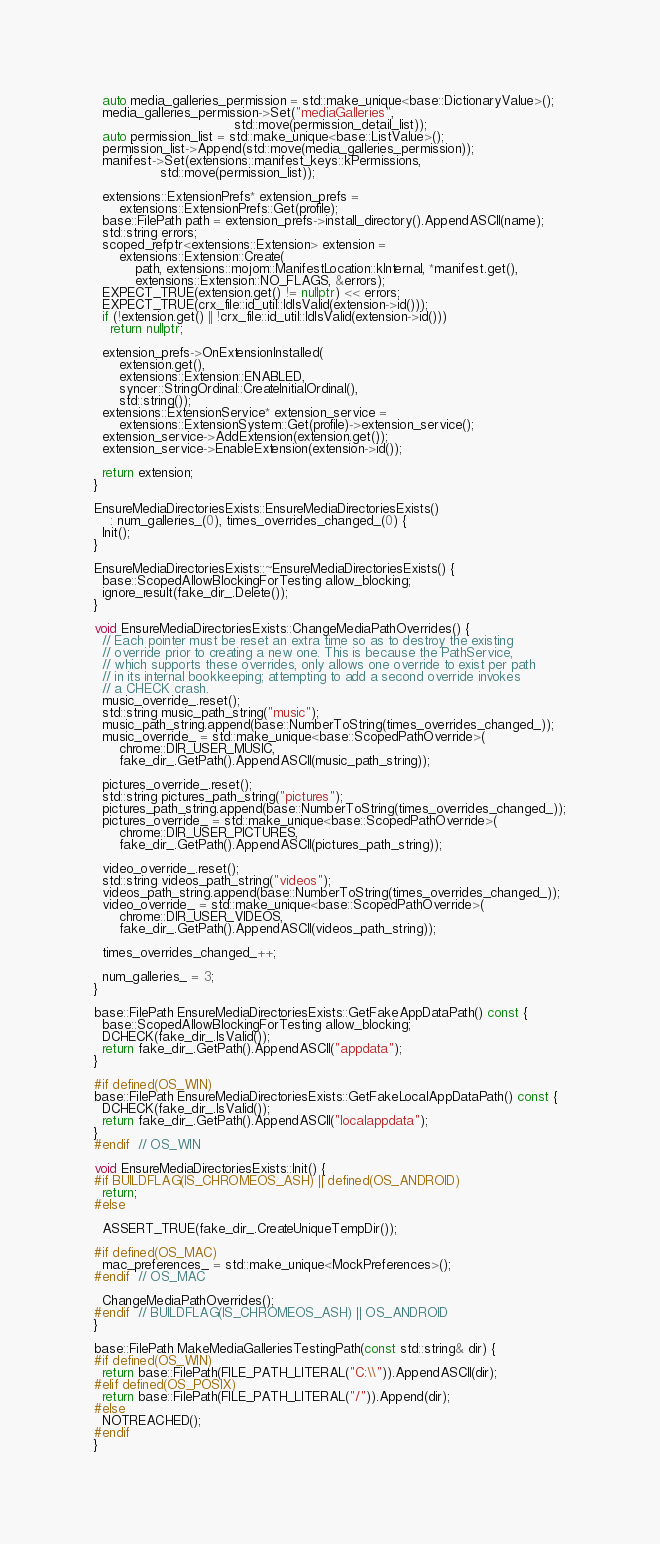Convert code to text. <code><loc_0><loc_0><loc_500><loc_500><_C++_>  auto media_galleries_permission = std::make_unique<base::DictionaryValue>();
  media_galleries_permission->Set("mediaGalleries",
                                  std::move(permission_detail_list));
  auto permission_list = std::make_unique<base::ListValue>();
  permission_list->Append(std::move(media_galleries_permission));
  manifest->Set(extensions::manifest_keys::kPermissions,
                std::move(permission_list));

  extensions::ExtensionPrefs* extension_prefs =
      extensions::ExtensionPrefs::Get(profile);
  base::FilePath path = extension_prefs->install_directory().AppendASCII(name);
  std::string errors;
  scoped_refptr<extensions::Extension> extension =
      extensions::Extension::Create(
          path, extensions::mojom::ManifestLocation::kInternal, *manifest.get(),
          extensions::Extension::NO_FLAGS, &errors);
  EXPECT_TRUE(extension.get() != nullptr) << errors;
  EXPECT_TRUE(crx_file::id_util::IdIsValid(extension->id()));
  if (!extension.get() || !crx_file::id_util::IdIsValid(extension->id()))
    return nullptr;

  extension_prefs->OnExtensionInstalled(
      extension.get(),
      extensions::Extension::ENABLED,
      syncer::StringOrdinal::CreateInitialOrdinal(),
      std::string());
  extensions::ExtensionService* extension_service =
      extensions::ExtensionSystem::Get(profile)->extension_service();
  extension_service->AddExtension(extension.get());
  extension_service->EnableExtension(extension->id());

  return extension;
}

EnsureMediaDirectoriesExists::EnsureMediaDirectoriesExists()
    : num_galleries_(0), times_overrides_changed_(0) {
  Init();
}

EnsureMediaDirectoriesExists::~EnsureMediaDirectoriesExists() {
  base::ScopedAllowBlockingForTesting allow_blocking;
  ignore_result(fake_dir_.Delete());
}

void EnsureMediaDirectoriesExists::ChangeMediaPathOverrides() {
  // Each pointer must be reset an extra time so as to destroy the existing
  // override prior to creating a new one. This is because the PathService,
  // which supports these overrides, only allows one override to exist per path
  // in its internal bookkeeping; attempting to add a second override invokes
  // a CHECK crash.
  music_override_.reset();
  std::string music_path_string("music");
  music_path_string.append(base::NumberToString(times_overrides_changed_));
  music_override_ = std::make_unique<base::ScopedPathOverride>(
      chrome::DIR_USER_MUSIC,
      fake_dir_.GetPath().AppendASCII(music_path_string));

  pictures_override_.reset();
  std::string pictures_path_string("pictures");
  pictures_path_string.append(base::NumberToString(times_overrides_changed_));
  pictures_override_ = std::make_unique<base::ScopedPathOverride>(
      chrome::DIR_USER_PICTURES,
      fake_dir_.GetPath().AppendASCII(pictures_path_string));

  video_override_.reset();
  std::string videos_path_string("videos");
  videos_path_string.append(base::NumberToString(times_overrides_changed_));
  video_override_ = std::make_unique<base::ScopedPathOverride>(
      chrome::DIR_USER_VIDEOS,
      fake_dir_.GetPath().AppendASCII(videos_path_string));

  times_overrides_changed_++;

  num_galleries_ = 3;
}

base::FilePath EnsureMediaDirectoriesExists::GetFakeAppDataPath() const {
  base::ScopedAllowBlockingForTesting allow_blocking;
  DCHECK(fake_dir_.IsValid());
  return fake_dir_.GetPath().AppendASCII("appdata");
}

#if defined(OS_WIN)
base::FilePath EnsureMediaDirectoriesExists::GetFakeLocalAppDataPath() const {
  DCHECK(fake_dir_.IsValid());
  return fake_dir_.GetPath().AppendASCII("localappdata");
}
#endif  // OS_WIN

void EnsureMediaDirectoriesExists::Init() {
#if BUILDFLAG(IS_CHROMEOS_ASH) || defined(OS_ANDROID)
  return;
#else

  ASSERT_TRUE(fake_dir_.CreateUniqueTempDir());

#if defined(OS_MAC)
  mac_preferences_ = std::make_unique<MockPreferences>();
#endif  // OS_MAC

  ChangeMediaPathOverrides();
#endif  // BUILDFLAG(IS_CHROMEOS_ASH) || OS_ANDROID
}

base::FilePath MakeMediaGalleriesTestingPath(const std::string& dir) {
#if defined(OS_WIN)
  return base::FilePath(FILE_PATH_LITERAL("C:\\")).AppendASCII(dir);
#elif defined(OS_POSIX)
  return base::FilePath(FILE_PATH_LITERAL("/")).Append(dir);
#else
  NOTREACHED();
#endif
}
</code> 